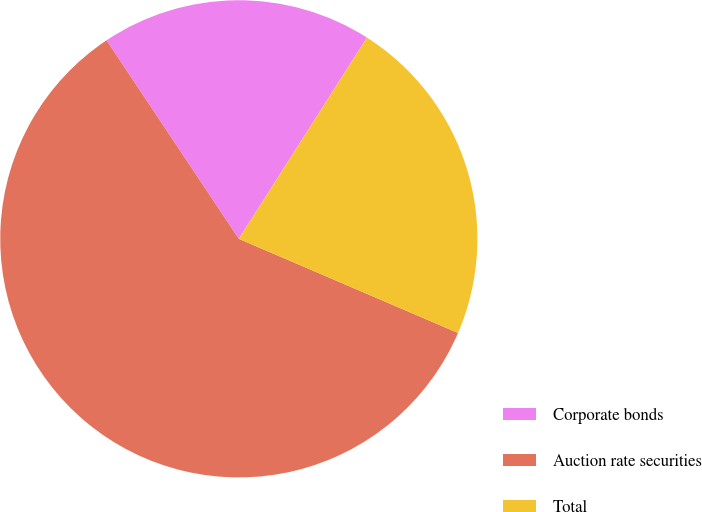Convert chart to OTSL. <chart><loc_0><loc_0><loc_500><loc_500><pie_chart><fcel>Corporate bonds<fcel>Auction rate securities<fcel>Total<nl><fcel>18.38%<fcel>59.19%<fcel>22.43%<nl></chart> 